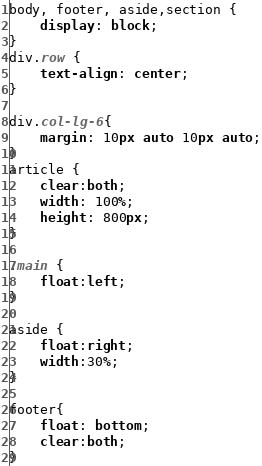<code> <loc_0><loc_0><loc_500><loc_500><_CSS_>body, footer, aside,section {
	display: block;
}
div.row {
	text-align: center;
}

div.col-lg-6{
	margin: 10px auto 10px auto;
}
article {
	clear:both;
	width: 100%;
	height: 800px;
}

.main {
	float:left;
}

aside {
	float:right;
	width:30%;
}

footer{
	float: bottom;
	clear:both;
}</code> 